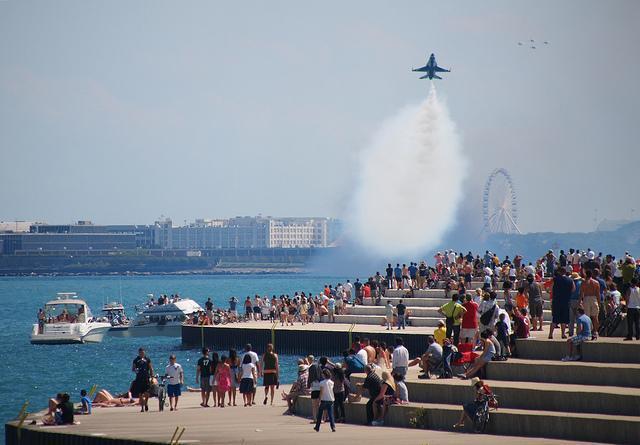How many suitcases are shown?
Give a very brief answer. 0. 